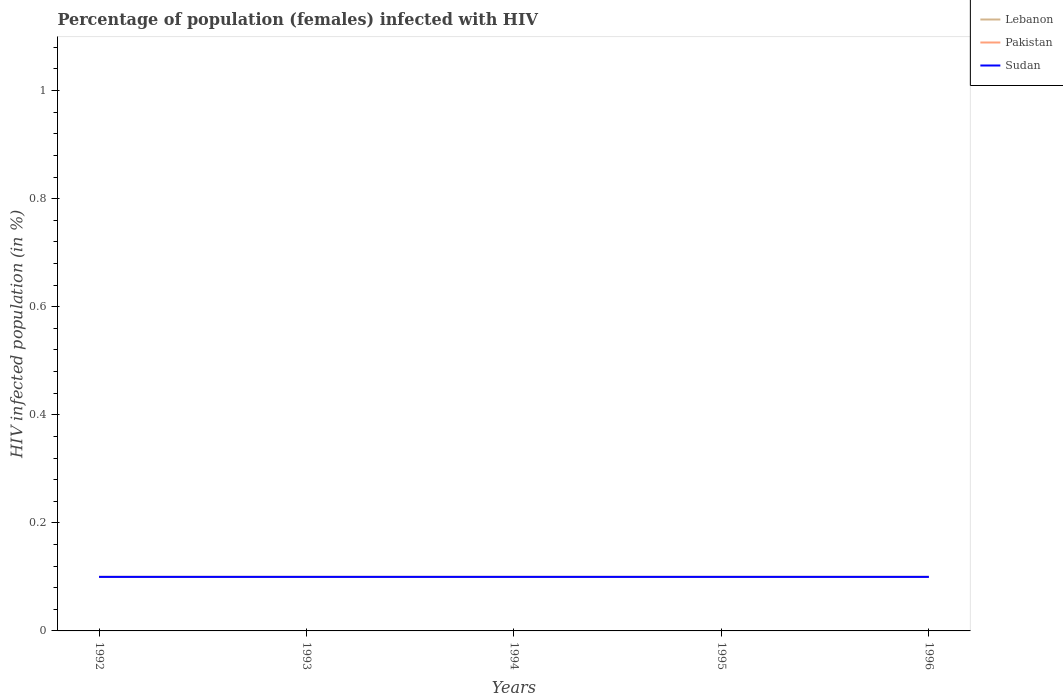How many different coloured lines are there?
Your response must be concise. 3. Does the line corresponding to Sudan intersect with the line corresponding to Lebanon?
Provide a succinct answer. Yes. Across all years, what is the maximum percentage of HIV infected female population in Pakistan?
Keep it short and to the point. 0.1. In which year was the percentage of HIV infected female population in Lebanon maximum?
Ensure brevity in your answer.  1992. What is the total percentage of HIV infected female population in Lebanon in the graph?
Give a very brief answer. 0. What is the difference between the highest and the second highest percentage of HIV infected female population in Sudan?
Make the answer very short. 0. Is the percentage of HIV infected female population in Pakistan strictly greater than the percentage of HIV infected female population in Lebanon over the years?
Ensure brevity in your answer.  No. How many years are there in the graph?
Offer a terse response. 5. Are the values on the major ticks of Y-axis written in scientific E-notation?
Ensure brevity in your answer.  No. Does the graph contain any zero values?
Offer a terse response. No. What is the title of the graph?
Offer a very short reply. Percentage of population (females) infected with HIV. What is the label or title of the X-axis?
Make the answer very short. Years. What is the label or title of the Y-axis?
Make the answer very short. HIV infected population (in %). What is the HIV infected population (in %) in Lebanon in 1992?
Make the answer very short. 0.1. What is the HIV infected population (in %) in Lebanon in 1993?
Your answer should be compact. 0.1. What is the HIV infected population (in %) of Pakistan in 1993?
Ensure brevity in your answer.  0.1. What is the HIV infected population (in %) in Sudan in 1993?
Give a very brief answer. 0.1. What is the HIV infected population (in %) in Lebanon in 1994?
Your answer should be very brief. 0.1. What is the HIV infected population (in %) of Sudan in 1995?
Your response must be concise. 0.1. What is the HIV infected population (in %) of Pakistan in 1996?
Offer a very short reply. 0.1. Across all years, what is the maximum HIV infected population (in %) of Lebanon?
Provide a short and direct response. 0.1. Across all years, what is the maximum HIV infected population (in %) in Pakistan?
Your answer should be compact. 0.1. Across all years, what is the maximum HIV infected population (in %) of Sudan?
Your answer should be very brief. 0.1. Across all years, what is the minimum HIV infected population (in %) of Lebanon?
Give a very brief answer. 0.1. Across all years, what is the minimum HIV infected population (in %) in Pakistan?
Make the answer very short. 0.1. What is the total HIV infected population (in %) of Lebanon in the graph?
Keep it short and to the point. 0.5. What is the total HIV infected population (in %) of Sudan in the graph?
Keep it short and to the point. 0.5. What is the difference between the HIV infected population (in %) of Pakistan in 1992 and that in 1993?
Ensure brevity in your answer.  0. What is the difference between the HIV infected population (in %) in Sudan in 1992 and that in 1993?
Make the answer very short. 0. What is the difference between the HIV infected population (in %) of Lebanon in 1993 and that in 1994?
Give a very brief answer. 0. What is the difference between the HIV infected population (in %) of Pakistan in 1993 and that in 1994?
Make the answer very short. 0. What is the difference between the HIV infected population (in %) of Sudan in 1993 and that in 1994?
Your answer should be very brief. 0. What is the difference between the HIV infected population (in %) in Lebanon in 1993 and that in 1995?
Offer a very short reply. 0. What is the difference between the HIV infected population (in %) in Pakistan in 1993 and that in 1995?
Ensure brevity in your answer.  0. What is the difference between the HIV infected population (in %) in Sudan in 1993 and that in 1996?
Keep it short and to the point. 0. What is the difference between the HIV infected population (in %) in Lebanon in 1994 and that in 1996?
Your answer should be very brief. 0. What is the difference between the HIV infected population (in %) in Pakistan in 1994 and that in 1996?
Your response must be concise. 0. What is the difference between the HIV infected population (in %) in Sudan in 1994 and that in 1996?
Your answer should be very brief. 0. What is the difference between the HIV infected population (in %) of Lebanon in 1995 and that in 1996?
Your response must be concise. 0. What is the difference between the HIV infected population (in %) of Lebanon in 1992 and the HIV infected population (in %) of Sudan in 1993?
Give a very brief answer. 0. What is the difference between the HIV infected population (in %) of Lebanon in 1992 and the HIV infected population (in %) of Pakistan in 1995?
Your answer should be very brief. 0. What is the difference between the HIV infected population (in %) of Lebanon in 1992 and the HIV infected population (in %) of Pakistan in 1996?
Make the answer very short. 0. What is the difference between the HIV infected population (in %) of Lebanon in 1992 and the HIV infected population (in %) of Sudan in 1996?
Offer a very short reply. 0. What is the difference between the HIV infected population (in %) in Pakistan in 1992 and the HIV infected population (in %) in Sudan in 1996?
Make the answer very short. 0. What is the difference between the HIV infected population (in %) of Lebanon in 1993 and the HIV infected population (in %) of Sudan in 1994?
Offer a very short reply. 0. What is the difference between the HIV infected population (in %) of Lebanon in 1993 and the HIV infected population (in %) of Pakistan in 1995?
Keep it short and to the point. 0. What is the difference between the HIV infected population (in %) in Lebanon in 1993 and the HIV infected population (in %) in Sudan in 1995?
Offer a terse response. 0. What is the difference between the HIV infected population (in %) of Pakistan in 1993 and the HIV infected population (in %) of Sudan in 1995?
Your answer should be compact. 0. What is the difference between the HIV infected population (in %) of Lebanon in 1994 and the HIV infected population (in %) of Pakistan in 1995?
Your answer should be very brief. 0. What is the difference between the HIV infected population (in %) in Pakistan in 1994 and the HIV infected population (in %) in Sudan in 1996?
Provide a succinct answer. 0. What is the average HIV infected population (in %) in Lebanon per year?
Your response must be concise. 0.1. What is the average HIV infected population (in %) of Pakistan per year?
Provide a short and direct response. 0.1. In the year 1992, what is the difference between the HIV infected population (in %) of Lebanon and HIV infected population (in %) of Pakistan?
Make the answer very short. 0. In the year 1992, what is the difference between the HIV infected population (in %) of Lebanon and HIV infected population (in %) of Sudan?
Your answer should be very brief. 0. In the year 1993, what is the difference between the HIV infected population (in %) in Lebanon and HIV infected population (in %) in Pakistan?
Provide a succinct answer. 0. In the year 1993, what is the difference between the HIV infected population (in %) in Pakistan and HIV infected population (in %) in Sudan?
Provide a succinct answer. 0. In the year 1994, what is the difference between the HIV infected population (in %) in Lebanon and HIV infected population (in %) in Pakistan?
Ensure brevity in your answer.  0. In the year 1994, what is the difference between the HIV infected population (in %) in Pakistan and HIV infected population (in %) in Sudan?
Your answer should be compact. 0. In the year 1995, what is the difference between the HIV infected population (in %) of Lebanon and HIV infected population (in %) of Sudan?
Your answer should be compact. 0. In the year 1995, what is the difference between the HIV infected population (in %) of Pakistan and HIV infected population (in %) of Sudan?
Your answer should be very brief. 0. In the year 1996, what is the difference between the HIV infected population (in %) of Lebanon and HIV infected population (in %) of Pakistan?
Provide a short and direct response. 0. What is the ratio of the HIV infected population (in %) in Lebanon in 1992 to that in 1993?
Give a very brief answer. 1. What is the ratio of the HIV infected population (in %) of Pakistan in 1992 to that in 1994?
Offer a terse response. 1. What is the ratio of the HIV infected population (in %) of Lebanon in 1992 to that in 1995?
Your answer should be compact. 1. What is the ratio of the HIV infected population (in %) of Lebanon in 1993 to that in 1994?
Your response must be concise. 1. What is the ratio of the HIV infected population (in %) of Pakistan in 1993 to that in 1994?
Make the answer very short. 1. What is the ratio of the HIV infected population (in %) of Sudan in 1993 to that in 1994?
Your answer should be compact. 1. What is the ratio of the HIV infected population (in %) in Lebanon in 1993 to that in 1995?
Your response must be concise. 1. What is the ratio of the HIV infected population (in %) in Sudan in 1993 to that in 1995?
Offer a very short reply. 1. What is the ratio of the HIV infected population (in %) in Lebanon in 1994 to that in 1995?
Ensure brevity in your answer.  1. What is the ratio of the HIV infected population (in %) in Sudan in 1994 to that in 1995?
Give a very brief answer. 1. What is the ratio of the HIV infected population (in %) of Lebanon in 1994 to that in 1996?
Provide a short and direct response. 1. What is the ratio of the HIV infected population (in %) of Pakistan in 1994 to that in 1996?
Offer a very short reply. 1. What is the ratio of the HIV infected population (in %) in Lebanon in 1995 to that in 1996?
Your answer should be compact. 1. What is the ratio of the HIV infected population (in %) of Pakistan in 1995 to that in 1996?
Give a very brief answer. 1. What is the difference between the highest and the lowest HIV infected population (in %) of Pakistan?
Make the answer very short. 0. What is the difference between the highest and the lowest HIV infected population (in %) of Sudan?
Provide a short and direct response. 0. 